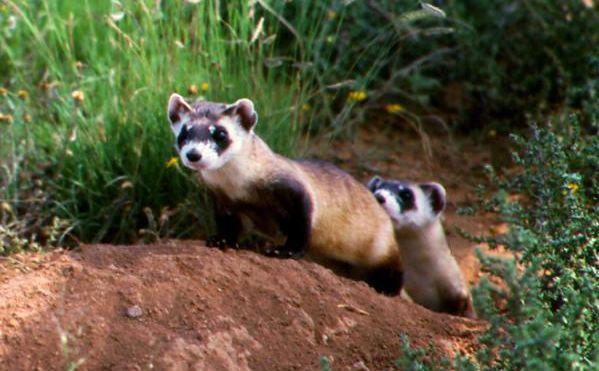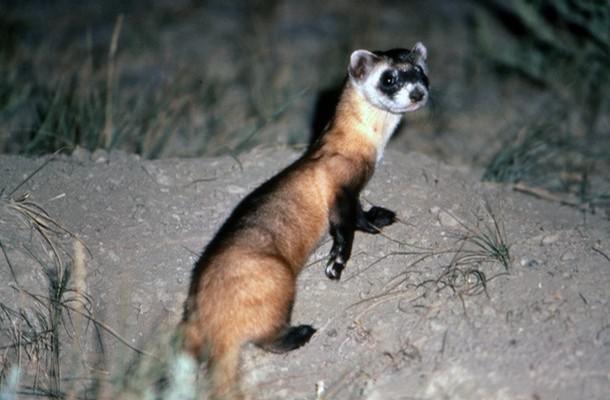The first image is the image on the left, the second image is the image on the right. Examine the images to the left and right. Is the description "at least one ferret is standing on the dirt with tufts of grass around it in the image pair" accurate? Answer yes or no. Yes. The first image is the image on the left, the second image is the image on the right. Evaluate the accuracy of this statement regarding the images: "There are two weasels that have black and white coloring.". Is it true? Answer yes or no. No. 